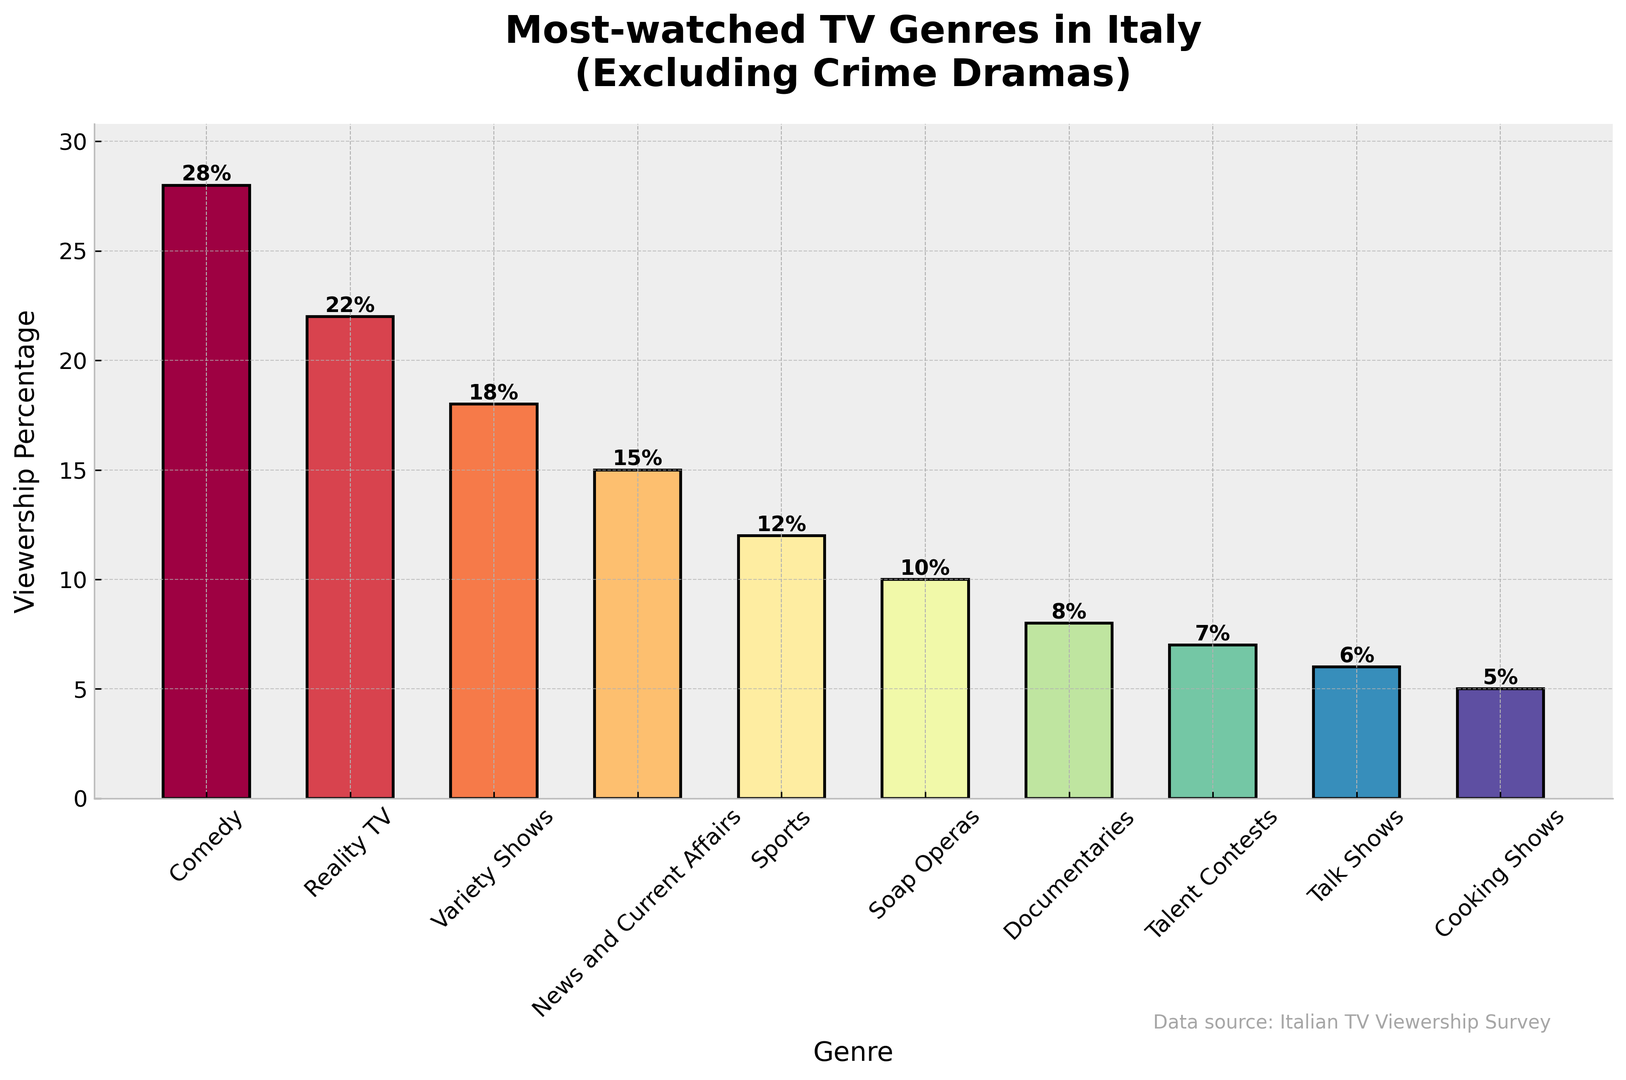What's the most popular TV genre in Italy? The tallest bar in the chart represents Comedy, indicating the highest viewership percentage. Thus, Comedy is the most popular TV genre.
Answer: Comedy Which genre has the least viewership percentage? The shortest bar represents Cooking Shows with a viewership percentage of 5%.
Answer: Cooking Shows What is the total viewership percentage for news-related genres (News and Current Affairs and Documentaries)? Adding the viewership percentages for News and Current Affairs (15%) and Documentaries (8%) gives the total viewership percentage. 15 + 8 = 23
Answer: 23% What is the difference in viewership between Comedy and Reality TV? Subtract the viewership percentage of Reality TV (22%) from that of Comedy (28%). 28 - 22 = 6
Answer: 6% Which genre has a higher viewership: Variety Shows or Sports? The bar for Variety Shows is taller than the bar for Sports, indicating a higher viewership percentage for Variety Shows (18%) compared to Sports (12%).
Answer: Variety Shows How many genres have a viewership percentage greater than 10%? Counting the bars that reach above the 10% mark: Comedy, Reality TV, Variety Shows, News and Current Affairs, and Sports. There are five such genres.
Answer: 5 Compare the combined viewership percentage of Reality TV and Talent Contests with that of the most-watched genre. Is it more or less? Combine the viewership percentages of Reality TV (22%) and Talent Contests (7%) which gives 22 + 7 = 29. The most-watched genre is Comedy with 28%. 29% is greater than 28%.
Answer: More Is the viewership of Soap Operas closer to that of News and Current Affairs or Sports? Soap Operas have a viewership percentage of 10%. The difference with News and Current Affairs (15%) is 5%, and with Sports (12%) is 2%. So, 10% is closer to 12% (Sports) than to 15% (News and Current Affairs).
Answer: Sports How much higher is the viewership percentage of Variety Shows compared to Talent Contests? Subtract the viewership percentage of Talent Contests (7%) from that of Variety Shows (18%). 18 - 7 = 11
Answer: 11% What is the average viewership percentage of the top three genres? The top three genres are Comedy (28%), Reality TV (22%), and Variety Shows (18%). The sum is 28 + 22 + 18 = 68. The average is 68 / 3 ≈ 22.67
Answer: 22.67% Which genre has a viewership percentage that is exactly twice that of Cooking Shows? Cooking Shows have a viewership percentage of 5%. Doubling this gives 5 * 2 = 10%. Soap Operas have a viewership percentage of 10%.
Answer: Soap Operas 